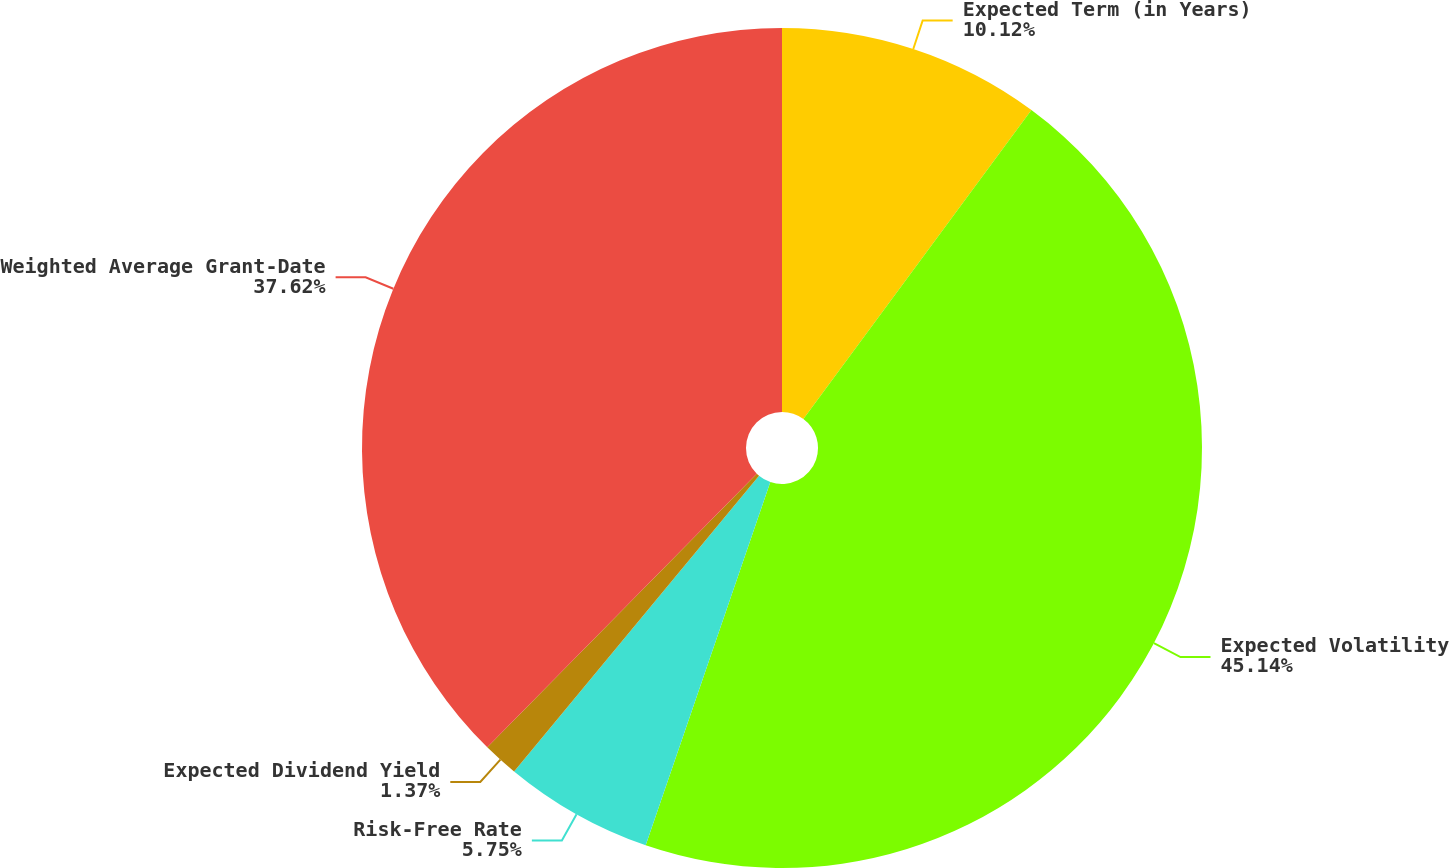Convert chart. <chart><loc_0><loc_0><loc_500><loc_500><pie_chart><fcel>Expected Term (in Years)<fcel>Expected Volatility<fcel>Risk-Free Rate<fcel>Expected Dividend Yield<fcel>Weighted Average Grant-Date<nl><fcel>10.12%<fcel>45.14%<fcel>5.75%<fcel>1.37%<fcel>37.62%<nl></chart> 